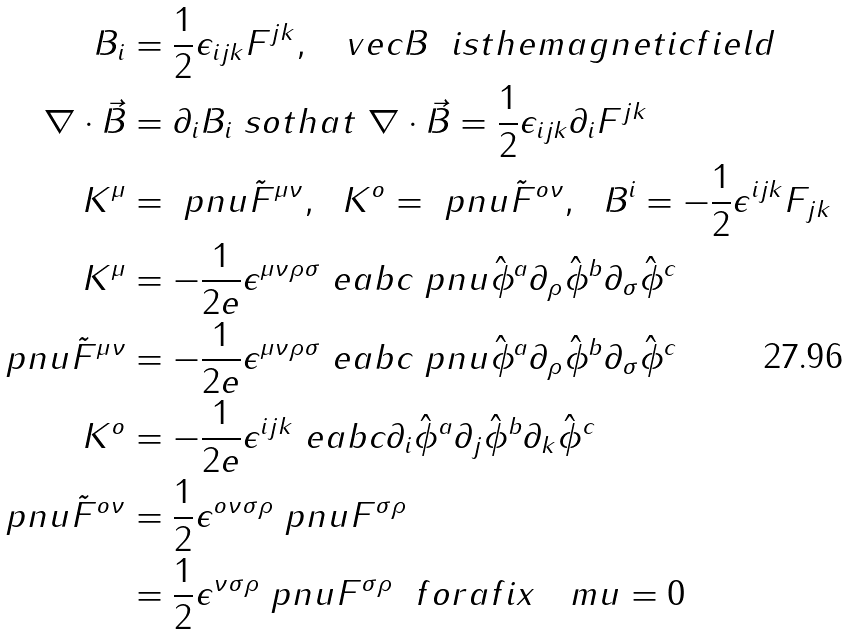Convert formula to latex. <formula><loc_0><loc_0><loc_500><loc_500>B _ { i } & = \frac { 1 } { 2 } \epsilon _ { i j k } F ^ { j k } , \ \ \ v e c { B } \ \ i s t h e m a g n e t i c f i e l d \\ \nabla \cdot \vec { B } & = \partial _ { i } B _ { i } \ s o t h a t \ \nabla \cdot \vec { B } = \frac { 1 } { 2 } \epsilon _ { i j k } \partial _ { i } F ^ { j k } \\ K ^ { \mu } & = \ p n u \tilde { F } ^ { \mu \nu } , \ \ K ^ { o } = \ p n u \tilde { F } ^ { o \nu } , \ \ B ^ { i } = - \frac { 1 } { 2 } \epsilon ^ { i j k } F _ { j k } \\ K ^ { \mu } & = - \frac { 1 } { 2 e } \epsilon ^ { \mu \nu \rho \sigma } \ e a b c \ p n u \hat { \phi } ^ { a } \partial _ { \rho } \hat { \phi } ^ { b } \partial _ { \sigma } \hat { \phi } ^ { c } \\ \ p n u \tilde { F } ^ { \mu \nu } & = - \frac { 1 } { 2 e } \epsilon ^ { \mu \nu \rho \sigma } \ e a b c \ p n u \hat { \phi } ^ { a } \partial _ { \rho } \hat { \phi } ^ { b } \partial _ { \sigma } \hat { \phi } ^ { c } \\ K ^ { o } & = - \frac { 1 } { 2 e } \epsilon ^ { i j k } \ e a b c \partial _ { i } \hat { \phi } ^ { a } \partial _ { j } \hat { \phi } ^ { b } \partial _ { k } \hat { \phi } ^ { c } \\ \ p n u \tilde { F } ^ { o \nu } & = \frac { 1 } { 2 } \epsilon ^ { o \nu \sigma \rho } \ p n u F ^ { \sigma \rho } \\ & = \frac { 1 } { 2 } \epsilon ^ { \nu \sigma \rho } \ p n u F ^ { \sigma \rho } \ \ f o r a f i x \quad m u = 0</formula> 